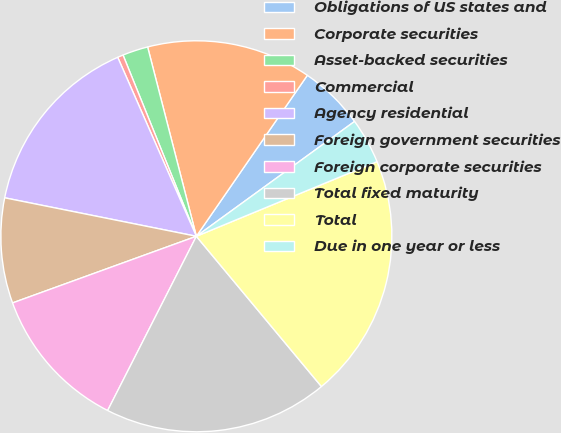<chart> <loc_0><loc_0><loc_500><loc_500><pie_chart><fcel>Obligations of US states and<fcel>Corporate securities<fcel>Asset-backed securities<fcel>Commercial<fcel>Agency residential<fcel>Foreign government securities<fcel>Foreign corporate securities<fcel>Total fixed maturity<fcel>Total<fcel>Due in one year or less<nl><fcel>5.4%<fcel>13.62%<fcel>2.11%<fcel>0.47%<fcel>15.26%<fcel>8.69%<fcel>11.97%<fcel>18.55%<fcel>20.19%<fcel>3.76%<nl></chart> 